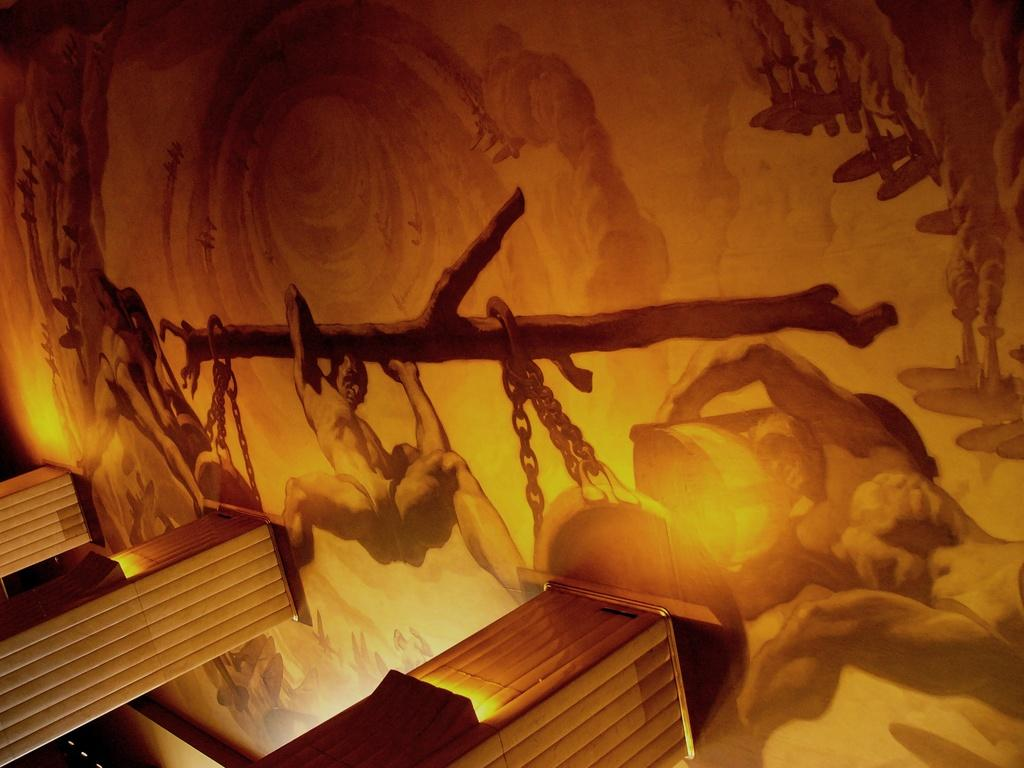What is present on the wall in the image? There is a painting on the wall in the image. What are the persons in the image doing? The persons are holding the trunk of a tree. How are the desks positioned in the image? The desks are attached to the wall in the image. What type of thrill can be seen in the painting on the wall? There is no indication of a thrill in the painting on the wall, as the content of the painting is not described in the facts. Is there a house visible in the image? The facts do not mention a house being present in the image. 